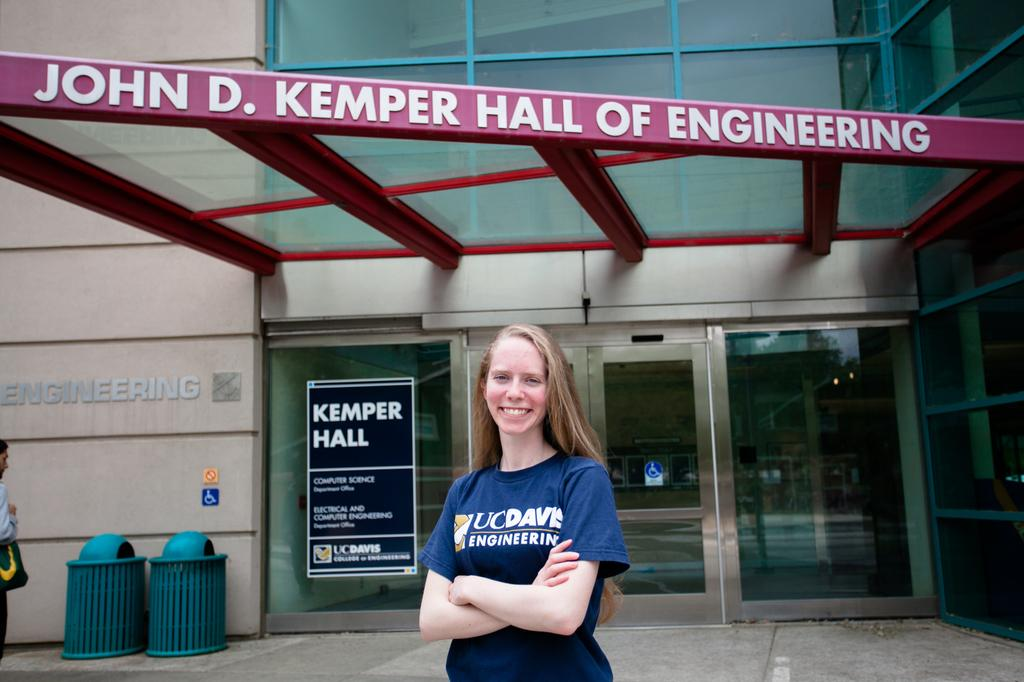<image>
Offer a succinct explanation of the picture presented. Girl is standing in front of a John D. Kemper Hall of Engineering 